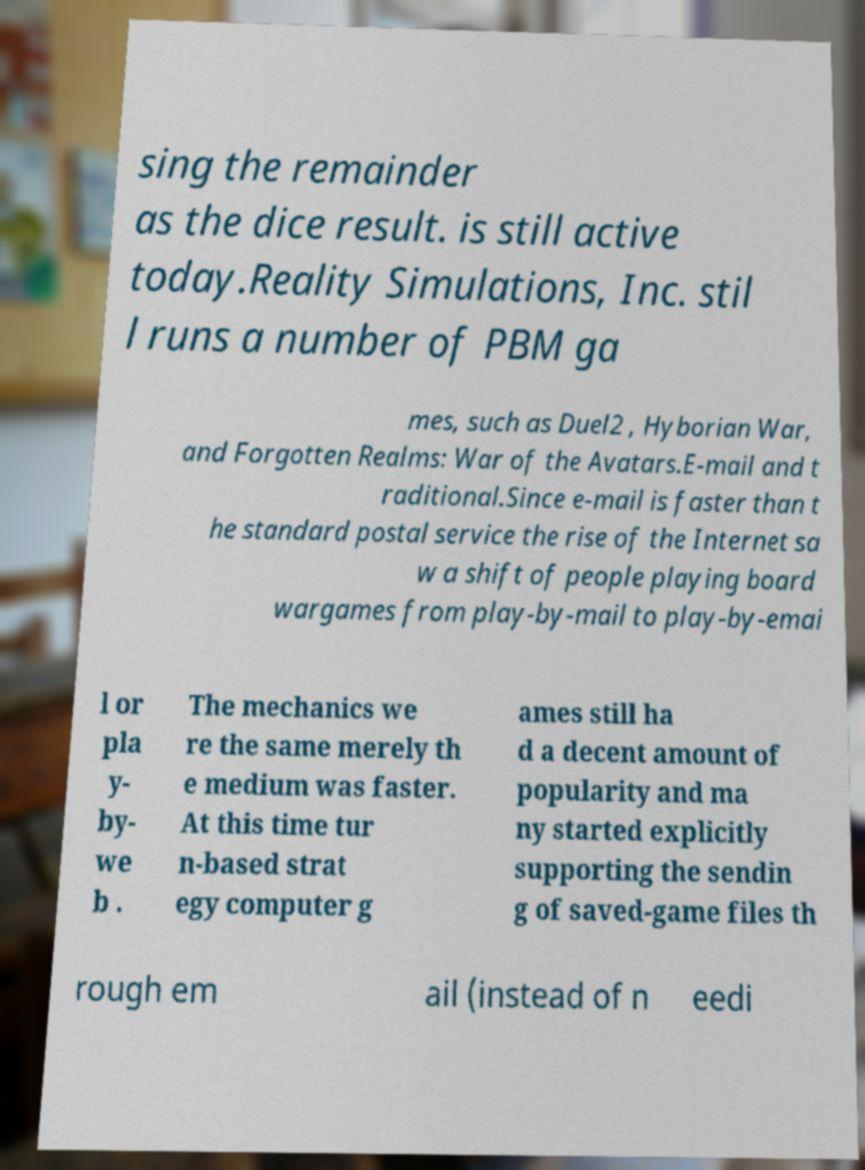I need the written content from this picture converted into text. Can you do that? sing the remainder as the dice result. is still active today.Reality Simulations, Inc. stil l runs a number of PBM ga mes, such as Duel2 , Hyborian War, and Forgotten Realms: War of the Avatars.E-mail and t raditional.Since e-mail is faster than t he standard postal service the rise of the Internet sa w a shift of people playing board wargames from play-by-mail to play-by-emai l or pla y- by- we b . The mechanics we re the same merely th e medium was faster. At this time tur n-based strat egy computer g ames still ha d a decent amount of popularity and ma ny started explicitly supporting the sendin g of saved-game files th rough em ail (instead of n eedi 